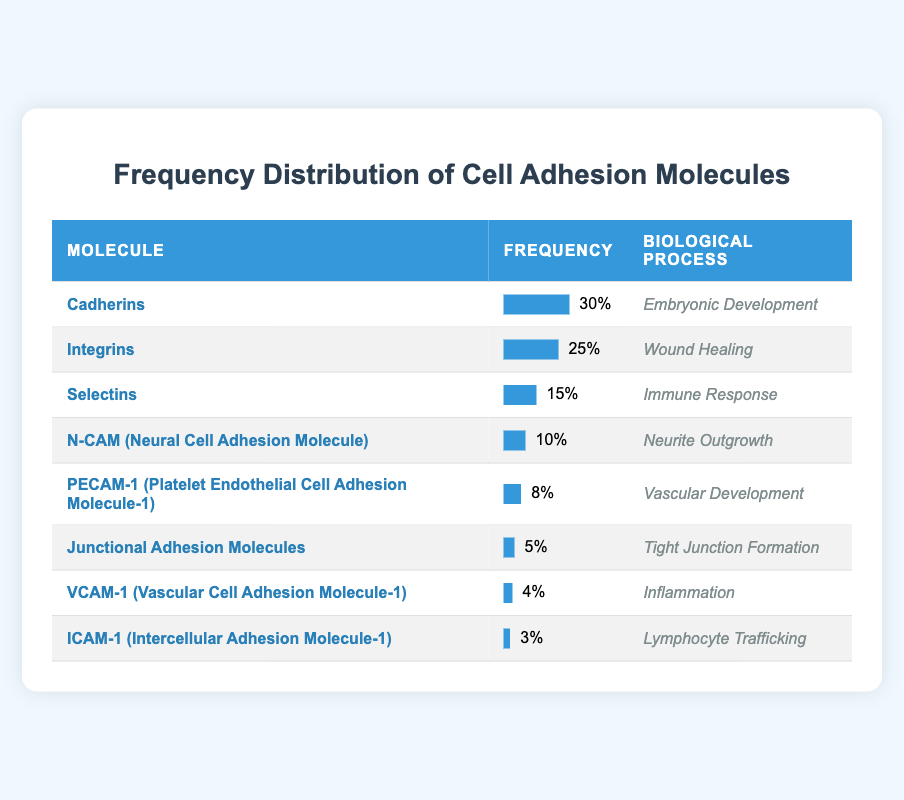What is the most frequent type of cell adhesion molecule listed in the table? Looking through the frequency column, Cadherins have the highest frequency value of 30, which is greater than all other values in the table.
Answer: Cadherins Which biological process is associated with the second most frequent cell adhesion molecule? By examining the frequencies, the second most frequent molecule is Integrins with a frequency of 25, which is associated with Wound Healing.
Answer: Wound Healing What is the total frequency of Selectins and N-CAM combined? The frequency of Selectins is 15 and N-CAM's frequency is 10. Adding these together (15 + 10) gives us a total frequency of 25.
Answer: 25 Is Junctional Adhesion Molecules more frequent than VCAM-1? Junctional Adhesion Molecules have a frequency of 5, while VCAM-1 has a frequency of 4. Since 5 is greater than 4, the statement is true.
Answer: Yes What is the frequency difference between Cadherins and ICAM-1? The frequency of Cadherins is 30, while the frequency of ICAM-1 is 3. The difference is 30 - 3 = 27.
Answer: 27 How many types of cell adhesion molecules listed have a frequency of 10 or greater? The molecules with a frequency of 10 or greater are Cadherins (30), Integrins (25), Selectins (15), and N-CAM (10). This makes a total of 4 types.
Answer: 4 Which biological process listed has the least frequency and what is that frequency? The lowest frequency in the table belongs to ICAM-1, which is associated with Lymphocyte Trafficking and has a frequency of 3.
Answer: Lymphocyte Trafficking, 3 If we exclude the two most frequent cell adhesion molecules, what is the average frequency of the remaining ones? Excluding Cadherins (30) and Integrins (25), we have Selectins (15), N-CAM (10), PECAM-1 (8), Junctional Adhesion Molecules (5), VCAM-1 (4), and ICAM-1 (3), which totals 45 for 6 molecules. The average frequency is 45/6 = 7.5.
Answer: 7.5 Which biological process is more frequent: Immune Response or Neurite Outgrowth? Selectins, associated with Immune Response, have a frequency of 15, while N-CAM, linked to Neurite Outgrowth, has a frequency of 10. Since 15 is more than 10, Immune Response is more frequent.
Answer: Immune Response 